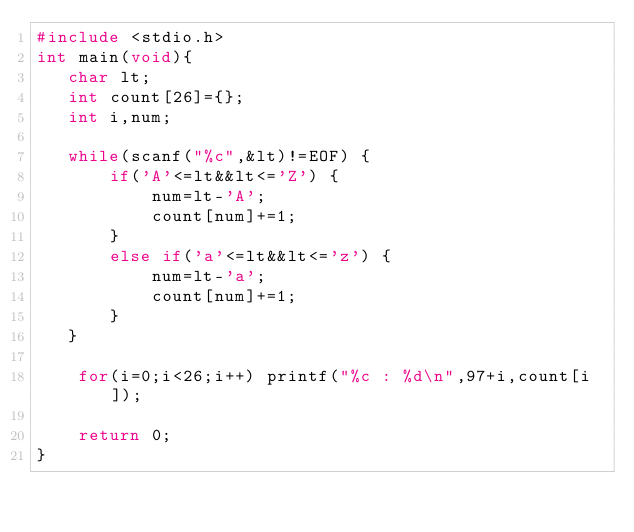<code> <loc_0><loc_0><loc_500><loc_500><_C_>#include <stdio.h>
int main(void){
   char lt;
   int count[26]={};
   int i,num;
   
   while(scanf("%c",&lt)!=EOF) {
       if('A'<=lt&&lt<='Z') {
           num=lt-'A';
           count[num]+=1;
       }
       else if('a'<=lt&&lt<='z') {
           num=lt-'a';
           count[num]+=1;
       }
   }
   
    for(i=0;i<26;i++) printf("%c : %d\n",97+i,count[i]);
   
    return 0;
}
</code> 